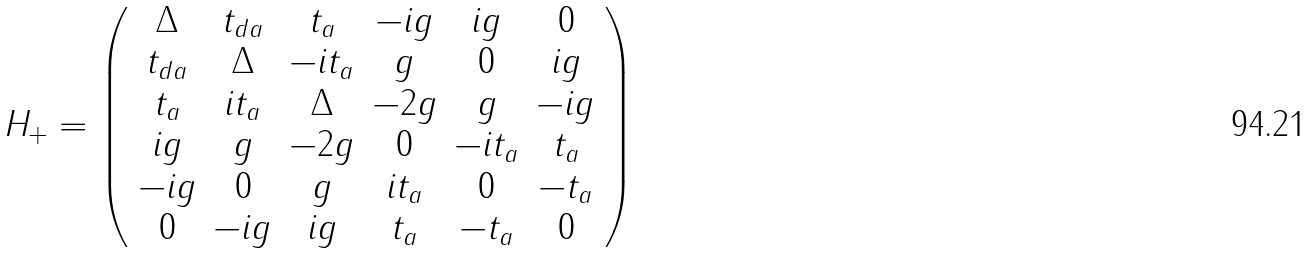<formula> <loc_0><loc_0><loc_500><loc_500>H _ { + } = \left ( \begin{array} { c c c c c c } \Delta & t _ { d a } & t _ { a } & - i g & i g & 0 \\ t _ { d a } & \Delta & - i t _ { a } & g & 0 & i g \\ t _ { a } & i t _ { a } & \Delta & - 2 g & g & - i g \\ i g & g & - 2 g & 0 & - i t _ { a } & t _ { a } \\ - i g & 0 & g & i t _ { a } & 0 & - t _ { a } \\ 0 & - i g & i g & t _ { a } & - t _ { a } & 0 \end{array} \right )</formula> 